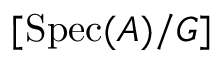<formula> <loc_0><loc_0><loc_500><loc_500>[ { S p e c } ( A ) / G ]</formula> 